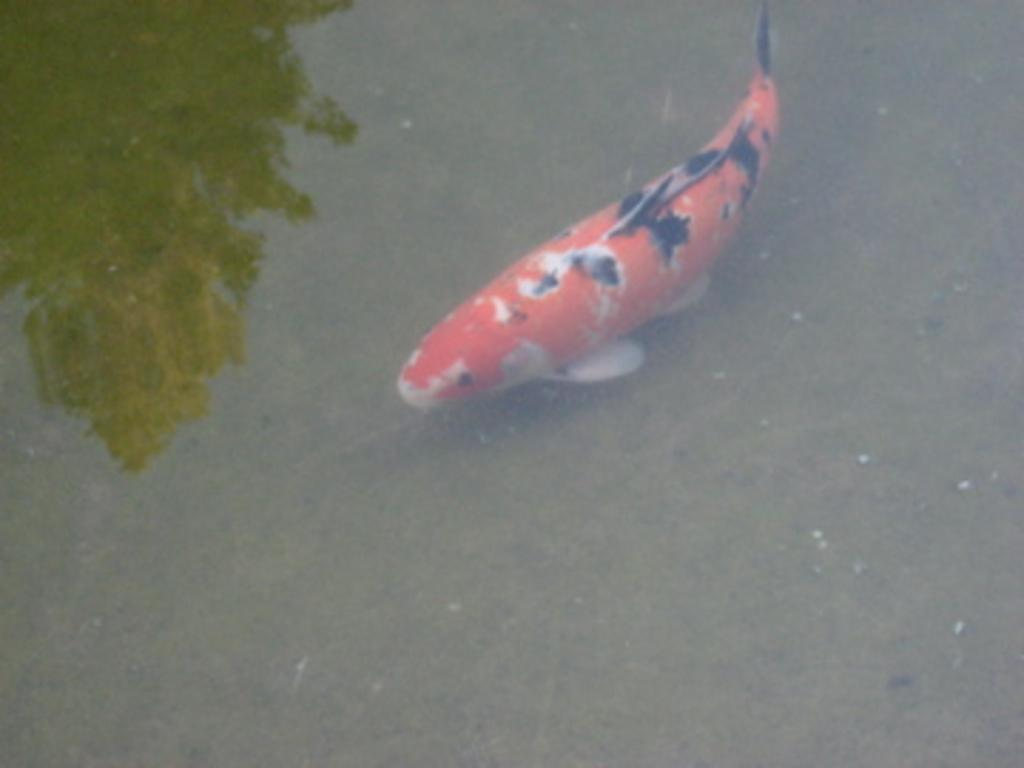What type of animal is in the image? There is a fish in the image. Can you describe the color pattern of the fish? The fish is orange, white, and black in color. Where is the fish located in the image? The fish is in the water. What can be seen in the water besides the fish? There is a reflection of a tree in the water. What type of sign can be seen on the table in the image? There is no table or sign present in the image; it features a fish in the water with a reflection of a tree. 